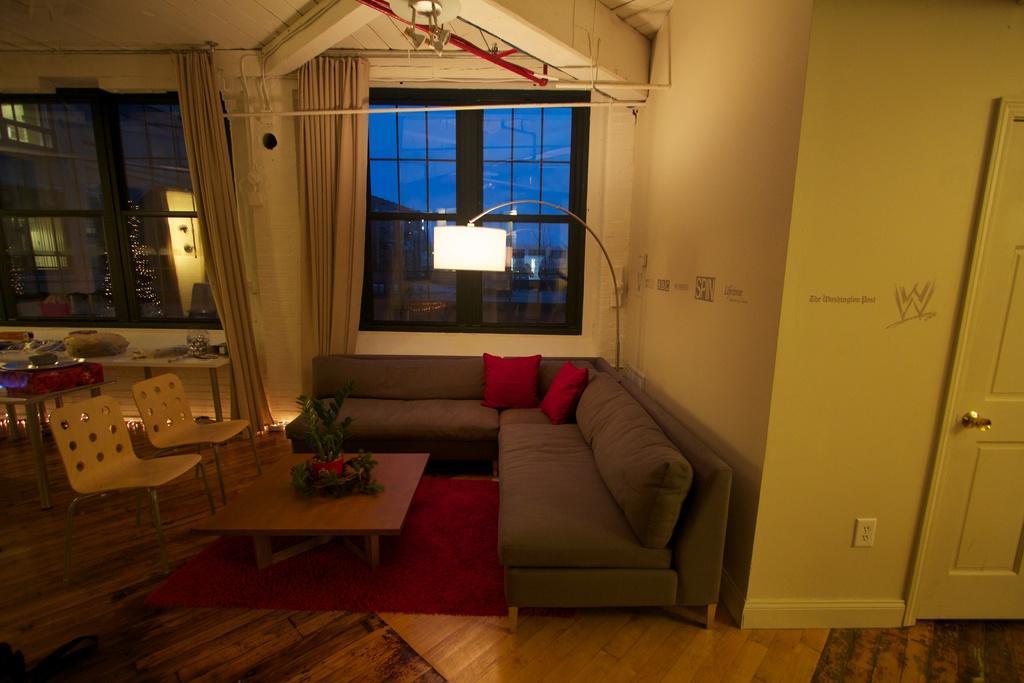Please provide a concise description of this image. The image is taken in the room. In the center of the image there is a sofa. There is a table and there are chairs. There is a decor placed on the table. On the right there is a door. At the bottom there is a mat placed on the floor. There is a lamp. In the background we can see windows and curtains. 